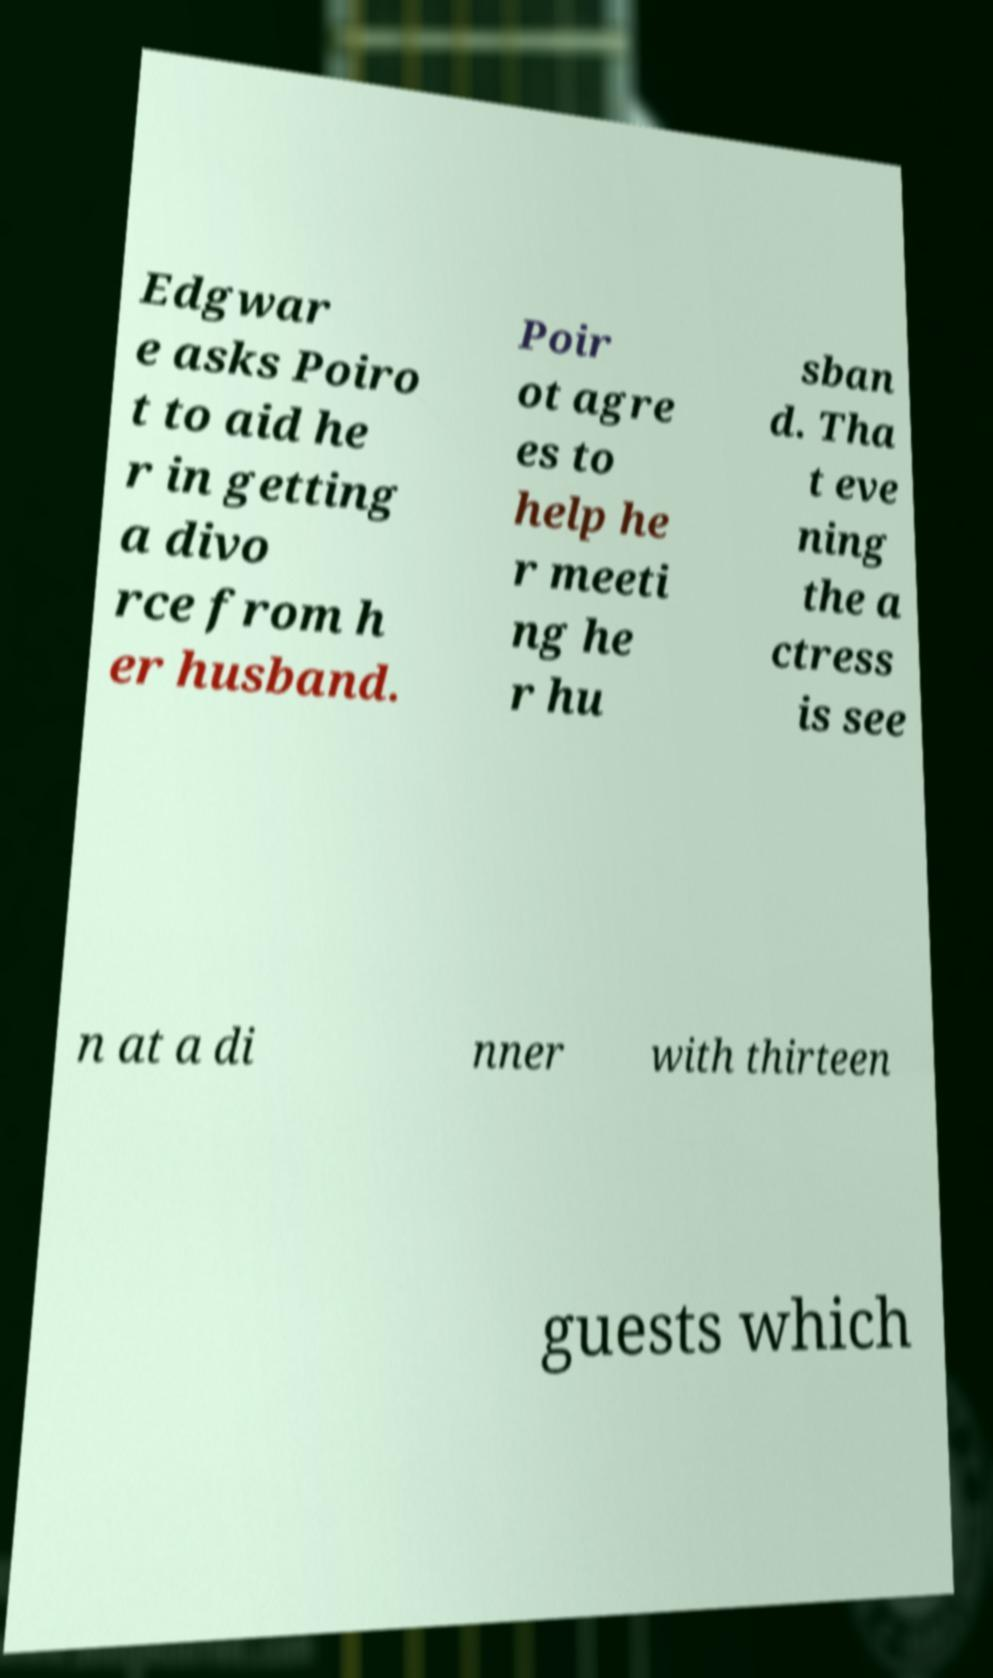For documentation purposes, I need the text within this image transcribed. Could you provide that? Edgwar e asks Poiro t to aid he r in getting a divo rce from h er husband. Poir ot agre es to help he r meeti ng he r hu sban d. Tha t eve ning the a ctress is see n at a di nner with thirteen guests which 